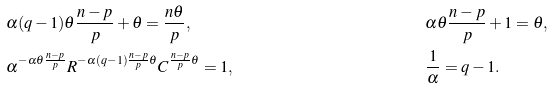Convert formula to latex. <formula><loc_0><loc_0><loc_500><loc_500>& \alpha ( q - 1 ) \theta \frac { n - p } { p } + \theta = \frac { n \theta } { p } , & & \alpha \theta \frac { n - p } { p } + 1 = \theta , \\ & \alpha ^ { - \alpha \theta \frac { n - p } { p } } R ^ { - \alpha ( q - 1 ) \frac { n - p } { p } \theta } C ^ { \frac { n - p } { p } \theta } = 1 , & & \frac { 1 } { \alpha } = q - 1 .</formula> 